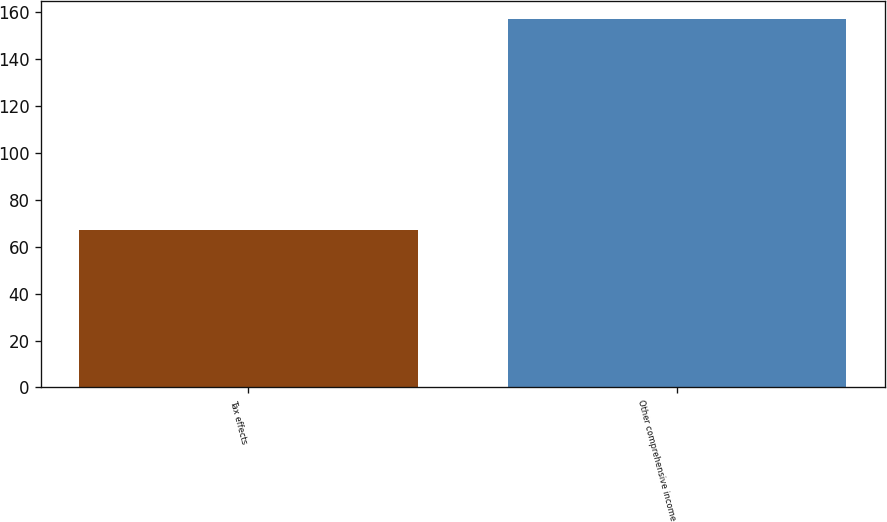<chart> <loc_0><loc_0><loc_500><loc_500><bar_chart><fcel>Tax effects<fcel>Other comprehensive income<nl><fcel>67<fcel>157<nl></chart> 